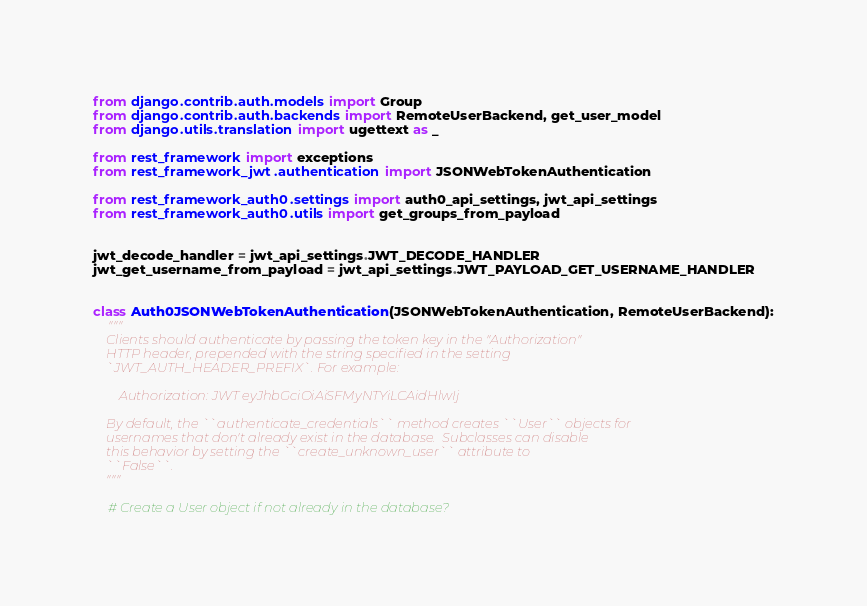Convert code to text. <code><loc_0><loc_0><loc_500><loc_500><_Python_>from django.contrib.auth.models import Group
from django.contrib.auth.backends import RemoteUserBackend, get_user_model
from django.utils.translation import ugettext as _

from rest_framework import exceptions
from rest_framework_jwt.authentication import JSONWebTokenAuthentication

from rest_framework_auth0.settings import auth0_api_settings, jwt_api_settings
from rest_framework_auth0.utils import get_groups_from_payload


jwt_decode_handler = jwt_api_settings.JWT_DECODE_HANDLER
jwt_get_username_from_payload = jwt_api_settings.JWT_PAYLOAD_GET_USERNAME_HANDLER


class Auth0JSONWebTokenAuthentication(JSONWebTokenAuthentication, RemoteUserBackend):
    """
    Clients should authenticate by passing the token key in the "Authorization"
    HTTP header, prepended with the string specified in the setting
    `JWT_AUTH_HEADER_PREFIX`. For example:

        Authorization: JWT eyJhbGciOiAiSFMyNTYiLCAidHlwIj

    By default, the ``authenticate_credentials`` method creates ``User`` objects for
    usernames that don't already exist in the database.  Subclasses can disable
    this behavior by setting the ``create_unknown_user`` attribute to
    ``False``.
    """

    # Create a User object if not already in the database?</code> 